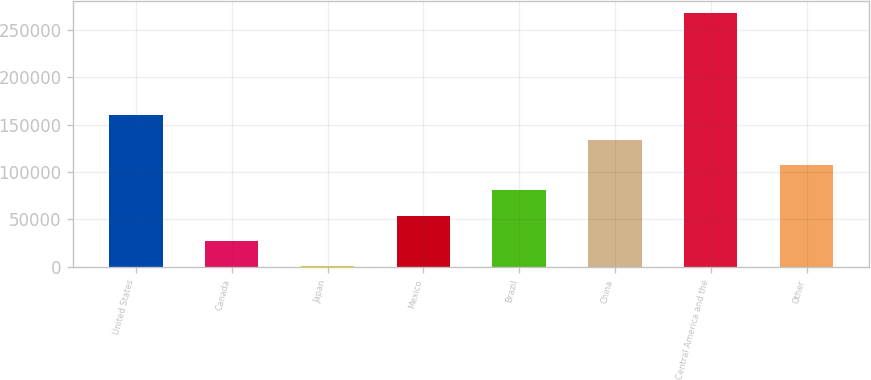Convert chart to OTSL. <chart><loc_0><loc_0><loc_500><loc_500><bar_chart><fcel>United States<fcel>Canada<fcel>Japan<fcel>Mexico<fcel>Brazil<fcel>China<fcel>Central America and the<fcel>Other<nl><fcel>160591<fcel>27234.4<fcel>563<fcel>53905.8<fcel>80577.2<fcel>133920<fcel>267277<fcel>107249<nl></chart> 